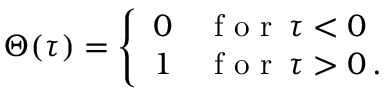<formula> <loc_0><loc_0><loc_500><loc_500>\Theta ( \tau ) = \left \{ \begin{array} { l l } { 0 } & { f o r \, \tau < 0 } \\ { 1 } & { f o r \, \tau > 0 \, . } \end{array}</formula> 